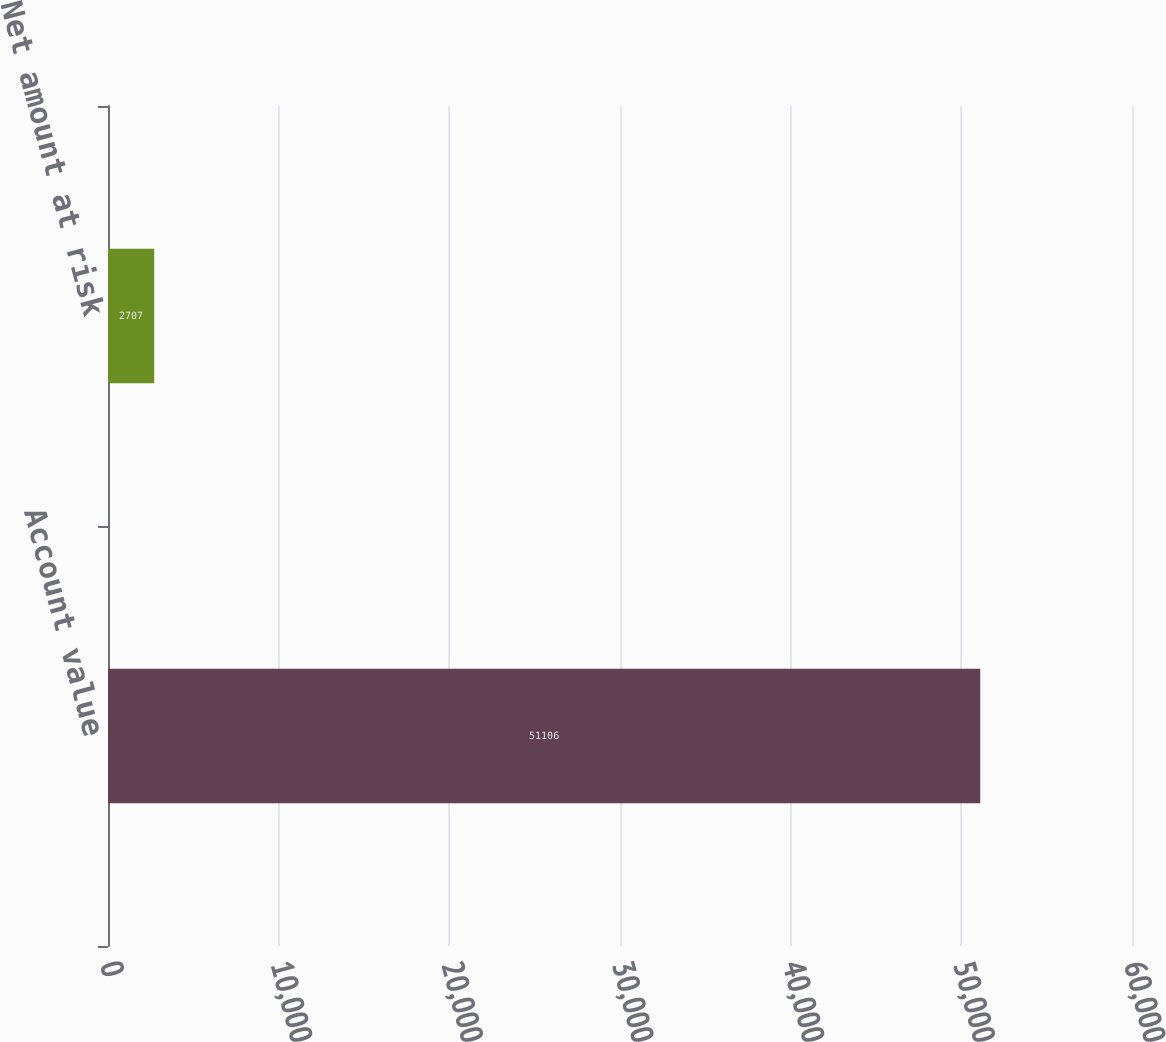Convert chart. <chart><loc_0><loc_0><loc_500><loc_500><bar_chart><fcel>Account value<fcel>Net amount at risk<nl><fcel>51106<fcel>2707<nl></chart> 